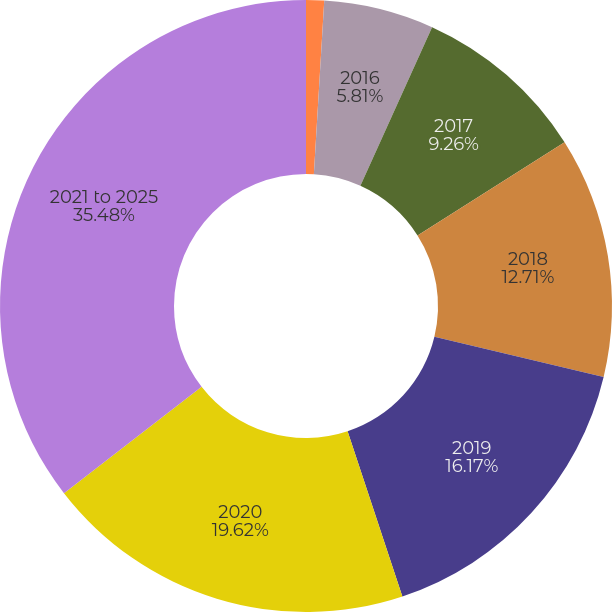Convert chart. <chart><loc_0><loc_0><loc_500><loc_500><pie_chart><fcel>Devon's 2016 contributions<fcel>2016<fcel>2017<fcel>2018<fcel>2019<fcel>2020<fcel>2021 to 2025<nl><fcel>0.95%<fcel>5.81%<fcel>9.26%<fcel>12.71%<fcel>16.17%<fcel>19.62%<fcel>35.48%<nl></chart> 